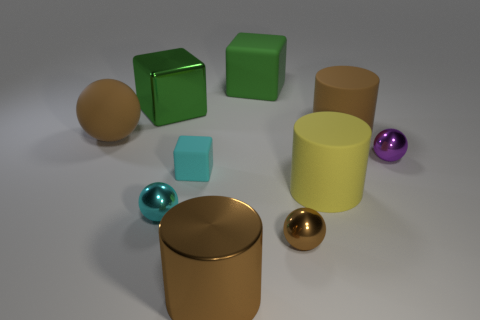Are there the same number of metal things on the right side of the green matte cube and brown balls?
Offer a terse response. Yes. Is the shape of the large yellow thing the same as the large thing on the right side of the big yellow thing?
Your answer should be very brief. Yes. The other matte object that is the same shape as the green matte object is what size?
Your answer should be very brief. Small. What number of other things are there of the same material as the yellow cylinder
Keep it short and to the point. 4. What is the purple sphere made of?
Make the answer very short. Metal. Is the color of the cylinder behind the large brown matte ball the same as the large shiny thing in front of the big sphere?
Keep it short and to the point. Yes. Is the number of shiny balls that are right of the small cyan rubber block greater than the number of big yellow objects?
Provide a succinct answer. Yes. What number of other things are there of the same color as the large metal cube?
Give a very brief answer. 1. Does the green object that is to the left of the cyan matte object have the same size as the cyan metal object?
Your answer should be compact. No. Are there any cyan matte things of the same size as the cyan sphere?
Make the answer very short. Yes. 